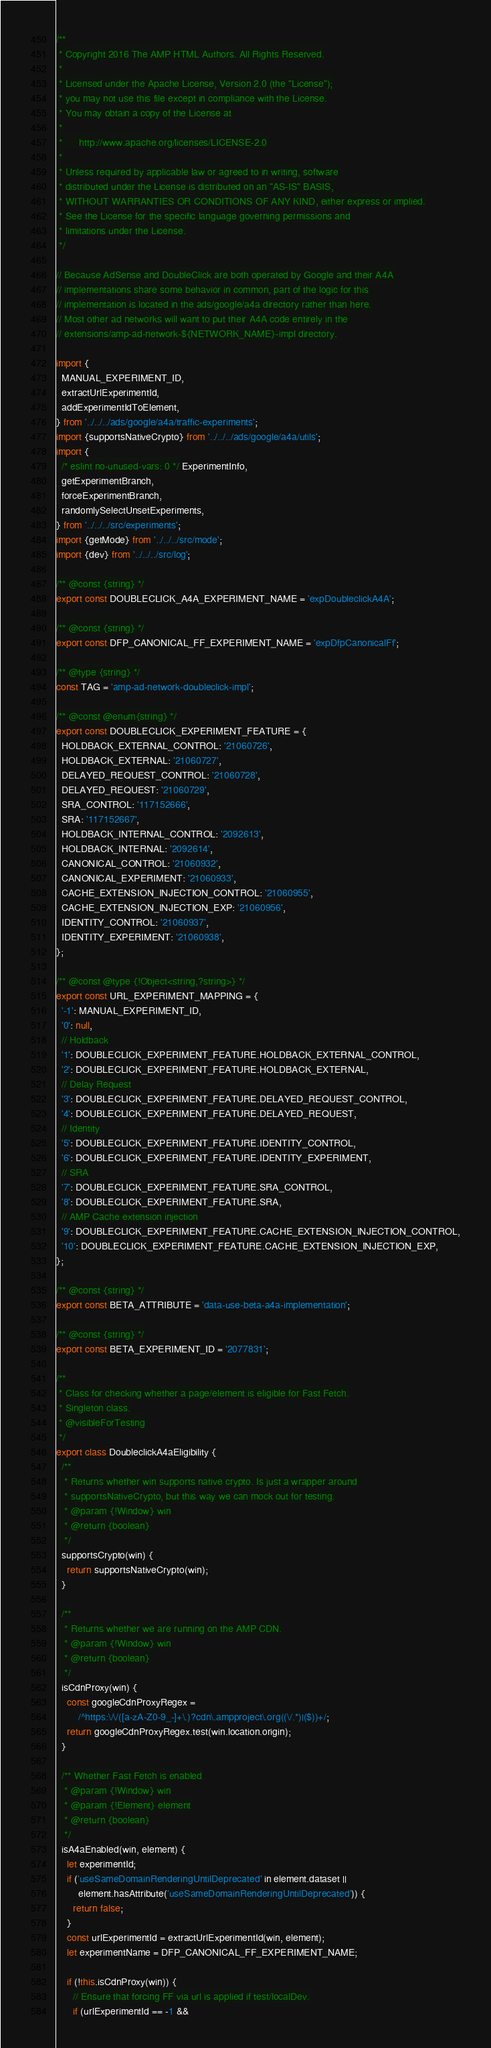<code> <loc_0><loc_0><loc_500><loc_500><_JavaScript_>/**
 * Copyright 2016 The AMP HTML Authors. All Rights Reserved.
 *
 * Licensed under the Apache License, Version 2.0 (the "License");
 * you may not use this file except in compliance with the License.
 * You may obtain a copy of the License at
 *
 *      http://www.apache.org/licenses/LICENSE-2.0
 *
 * Unless required by applicable law or agreed to in writing, software
 * distributed under the License is distributed on an "AS-IS" BASIS,
 * WITHOUT WARRANTIES OR CONDITIONS OF ANY KIND, either express or implied.
 * See the License for the specific language governing permissions and
 * limitations under the License.
 */

// Because AdSense and DoubleClick are both operated by Google and their A4A
// implementations share some behavior in common, part of the logic for this
// implementation is located in the ads/google/a4a directory rather than here.
// Most other ad networks will want to put their A4A code entirely in the
// extensions/amp-ad-network-${NETWORK_NAME}-impl directory.

import {
  MANUAL_EXPERIMENT_ID,
  extractUrlExperimentId,
  addExperimentIdToElement,
} from '../../../ads/google/a4a/traffic-experiments';
import {supportsNativeCrypto} from '../../../ads/google/a4a/utils';
import {
  /* eslint no-unused-vars: 0 */ ExperimentInfo,
  getExperimentBranch,
  forceExperimentBranch,
  randomlySelectUnsetExperiments,
} from '../../../src/experiments';
import {getMode} from '../../../src/mode';
import {dev} from '../../../src/log';

/** @const {string} */
export const DOUBLECLICK_A4A_EXPERIMENT_NAME = 'expDoubleclickA4A';

/** @const {string} */
export const DFP_CANONICAL_FF_EXPERIMENT_NAME = 'expDfpCanonicalFf';

/** @type {string} */
const TAG = 'amp-ad-network-doubleclick-impl';

/** @const @enum{string} */
export const DOUBLECLICK_EXPERIMENT_FEATURE = {
  HOLDBACK_EXTERNAL_CONTROL: '21060726',
  HOLDBACK_EXTERNAL: '21060727',
  DELAYED_REQUEST_CONTROL: '21060728',
  DELAYED_REQUEST: '21060729',
  SRA_CONTROL: '117152666',
  SRA: '117152667',
  HOLDBACK_INTERNAL_CONTROL: '2092613',
  HOLDBACK_INTERNAL: '2092614',
  CANONICAL_CONTROL: '21060932',
  CANONICAL_EXPERIMENT: '21060933',
  CACHE_EXTENSION_INJECTION_CONTROL: '21060955',
  CACHE_EXTENSION_INJECTION_EXP: '21060956',
  IDENTITY_CONTROL: '21060937',
  IDENTITY_EXPERIMENT: '21060938',
};

/** @const @type {!Object<string,?string>} */
export const URL_EXPERIMENT_MAPPING = {
  '-1': MANUAL_EXPERIMENT_ID,
  '0': null,
  // Holdback
  '1': DOUBLECLICK_EXPERIMENT_FEATURE.HOLDBACK_EXTERNAL_CONTROL,
  '2': DOUBLECLICK_EXPERIMENT_FEATURE.HOLDBACK_EXTERNAL,
  // Delay Request
  '3': DOUBLECLICK_EXPERIMENT_FEATURE.DELAYED_REQUEST_CONTROL,
  '4': DOUBLECLICK_EXPERIMENT_FEATURE.DELAYED_REQUEST,
  // Identity
  '5': DOUBLECLICK_EXPERIMENT_FEATURE.IDENTITY_CONTROL,
  '6': DOUBLECLICK_EXPERIMENT_FEATURE.IDENTITY_EXPERIMENT,
  // SRA
  '7': DOUBLECLICK_EXPERIMENT_FEATURE.SRA_CONTROL,
  '8': DOUBLECLICK_EXPERIMENT_FEATURE.SRA,
  // AMP Cache extension injection
  '9': DOUBLECLICK_EXPERIMENT_FEATURE.CACHE_EXTENSION_INJECTION_CONTROL,
  '10': DOUBLECLICK_EXPERIMENT_FEATURE.CACHE_EXTENSION_INJECTION_EXP,
};

/** @const {string} */
export const BETA_ATTRIBUTE = 'data-use-beta-a4a-implementation';

/** @const {string} */
export const BETA_EXPERIMENT_ID = '2077831';

/**
 * Class for checking whether a page/element is eligible for Fast Fetch.
 * Singleton class.
 * @visibleForTesting
 */
export class DoubleclickA4aEligibility {
  /**
   * Returns whether win supports native crypto. Is just a wrapper around
   * supportsNativeCrypto, but this way we can mock out for testing.
   * @param {!Window} win
   * @return {boolean}
   */
  supportsCrypto(win) {
    return supportsNativeCrypto(win);
  }

  /**
   * Returns whether we are running on the AMP CDN.
   * @param {!Window} win
   * @return {boolean}
   */
  isCdnProxy(win) {
    const googleCdnProxyRegex =
        /^https:\/\/([a-zA-Z0-9_-]+\.)?cdn\.ampproject\.org((\/.*)|($))+/;
    return googleCdnProxyRegex.test(win.location.origin);
  }

  /** Whether Fast Fetch is enabled
   * @param {!Window} win
   * @param {!Element} element
   * @return {boolean}
   */
  isA4aEnabled(win, element) {
    let experimentId;
    if ('useSameDomainRenderingUntilDeprecated' in element.dataset ||
        element.hasAttribute('useSameDomainRenderingUntilDeprecated')) {
      return false;
    }
    const urlExperimentId = extractUrlExperimentId(win, element);
    let experimentName = DFP_CANONICAL_FF_EXPERIMENT_NAME;

    if (!this.isCdnProxy(win)) {
      // Ensure that forcing FF via url is applied if test/localDev.
      if (urlExperimentId == -1 &&</code> 